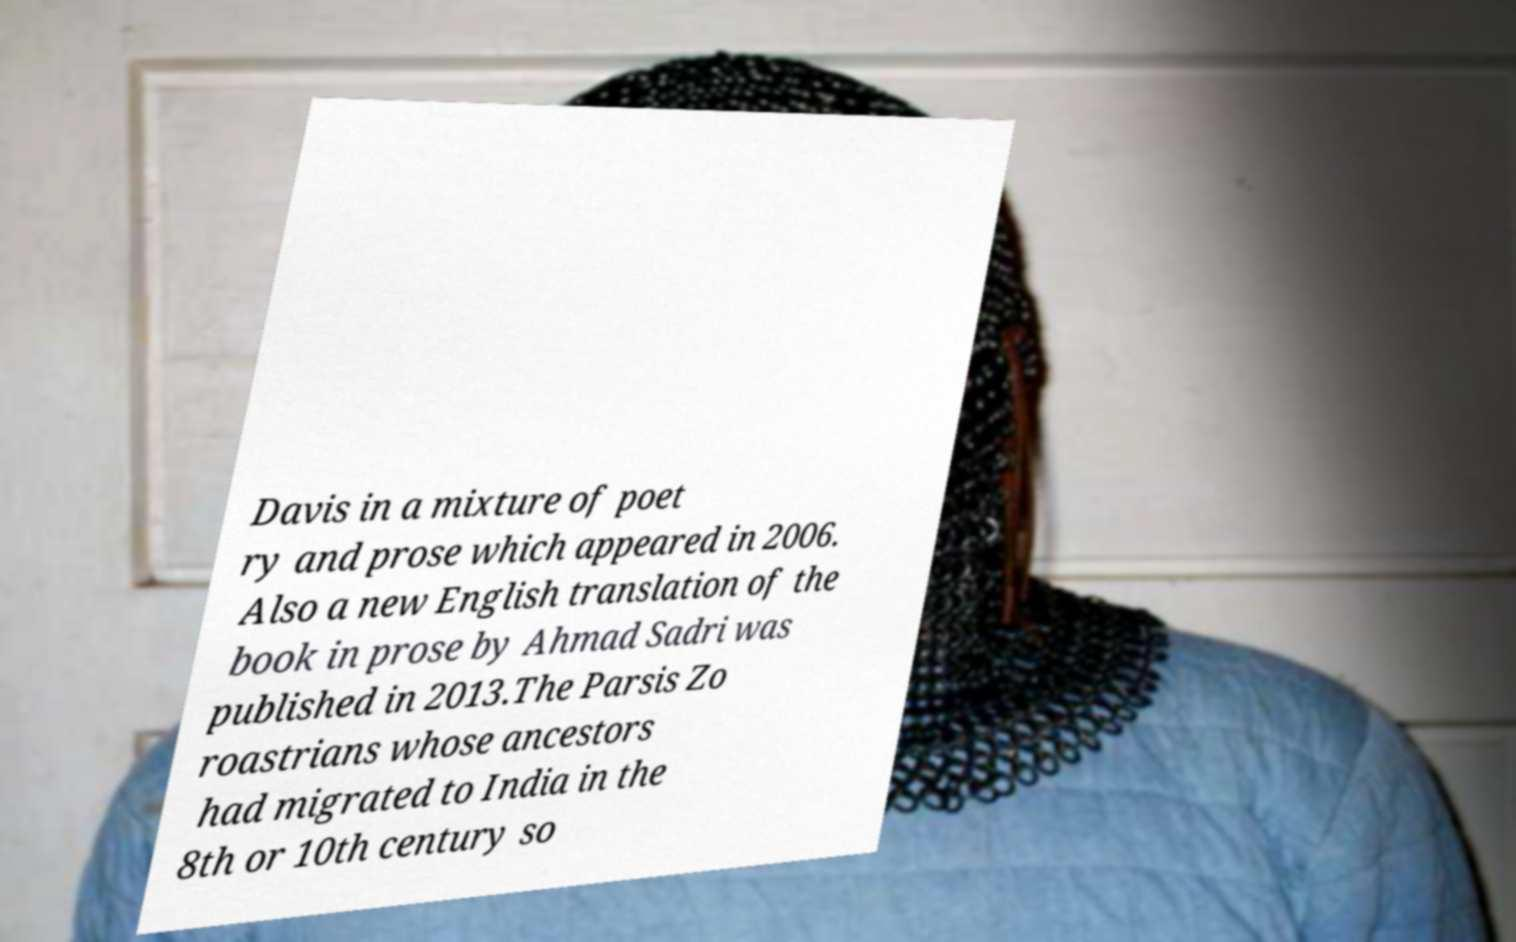I need the written content from this picture converted into text. Can you do that? Davis in a mixture of poet ry and prose which appeared in 2006. Also a new English translation of the book in prose by Ahmad Sadri was published in 2013.The Parsis Zo roastrians whose ancestors had migrated to India in the 8th or 10th century so 